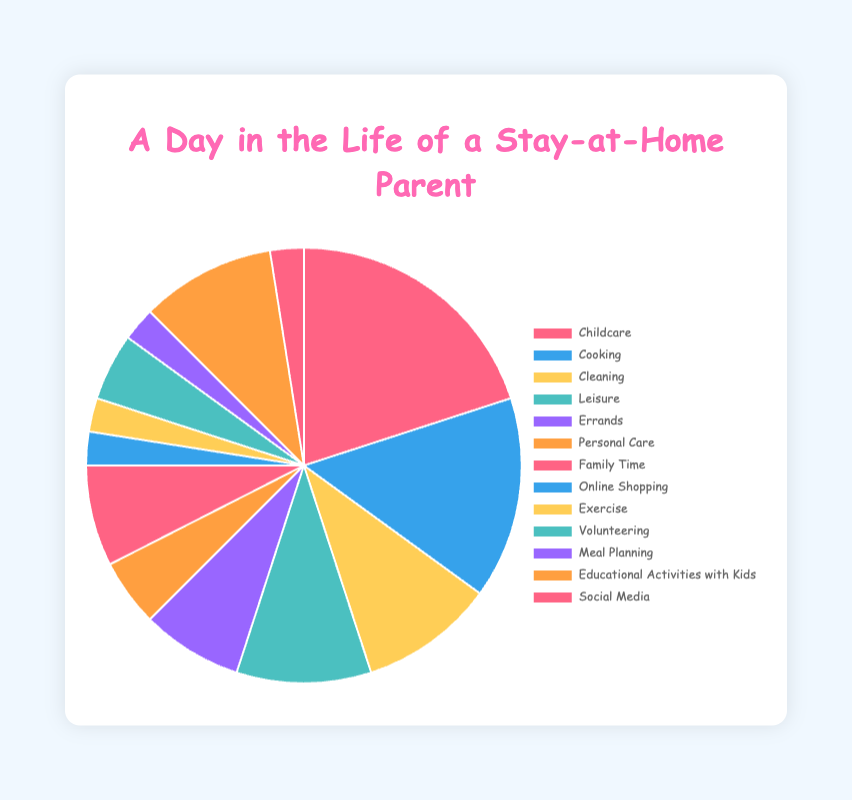What activity takes up the most time in a stay-at-home parent's day? By referring to the pie chart, we can visually see the largest segment. The biggest segment corresponds to Childcare.
Answer: Childcare How much more time is spent on Childcare compared to Cooking? The pie chart shows that Childcare has 4 hours and Cooking has 3 hours. The difference is 4 - 3 = 1 hour.
Answer: 1 hour Which activities each take up 2 hours of the day? By looking at the segments of the pie chart and their labels, we see that both Cleaning and Educational Activities with Kids each take up 2 hours.
Answer: Cleaning, Educational Activities with Kids What is the combined time spent on Family Time, Volunteering, and Personal Care? Adding the hours for Family Time (1.5), Volunteering (1), and Personal Care (1), we get 1.5 + 1 + 1 = 3.5 hours.
Answer: 3.5 hours Are there any activities that take up less than 1 hour? According to the pie chart, Online Shopping, Exercise, Meal Planning, and Social Media each take up 0.5 hours, which is less than 1 hour.
Answer: Online Shopping, Exercise, Meal Planning, Social Media What is the total time spent on Childcare, Online Shopping, and Social Media? By summing up the time for Childcare (4 hours), Online Shopping (0.5 hours), and Social Media (0.5 hours), we get 4 + 0.5 + 0.5 = 5 hours.
Answer: 5 hours Which activity has the smallest segment in the pie chart? The smallest segment visually in the pie chart corresponds to various activities, but among them, Online Shopping, Exercise, Meal Planning, and Social Media each have 0.5 hours. They all visually share the smallest segment.
Answer: Online Shopping, Exercise, Meal Planning, Social Media How does the time spent on Errands compare to the time spent on Family Time? The pie chart shows that both Errands and Family Time take up 1.5 hours each, so they are equal.
Answer: Equal What is the average time spent on Cooking, Cleaning, and Leisure? Add the hours for Cooking (3), Cleaning (2), and Leisure (2), then divide by the number of activities. (3 + 2 + 2) / 3 = 7 / 3 ≈ 2.33 hours.
Answer: 2.33 hours If you combine the time spent on Personal Care and Exercise, how does it compare to the time spent on Cooking? Summing Personal Care (1 hour) and Exercise (0.5 hours), we get 1 + 0.5 = 1.5 hours. Cooking takes 3 hours. So, 1.5 is less than 3.
Answer: Less than Cooking 